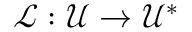<formula> <loc_0><loc_0><loc_500><loc_500>\mathcal { L } \colon \mathcal { U } \to \mathcal { U } ^ { * }</formula> 